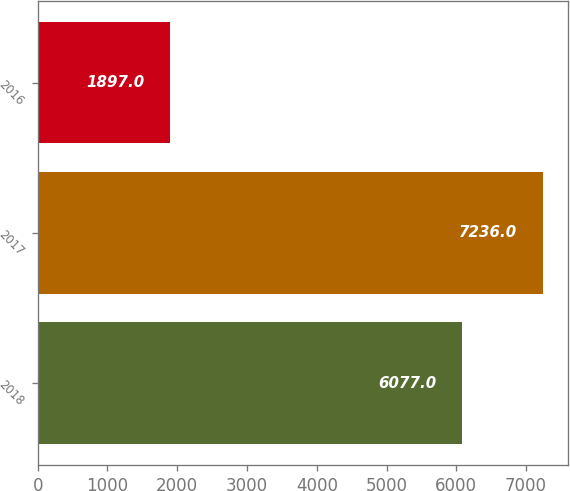Convert chart. <chart><loc_0><loc_0><loc_500><loc_500><bar_chart><fcel>2018<fcel>2017<fcel>2016<nl><fcel>6077<fcel>7236<fcel>1897<nl></chart> 